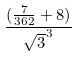Convert formula to latex. <formula><loc_0><loc_0><loc_500><loc_500>\frac { ( \frac { 7 } { 3 6 2 } + 8 ) } { \sqrt { 3 } ^ { 3 } }</formula> 